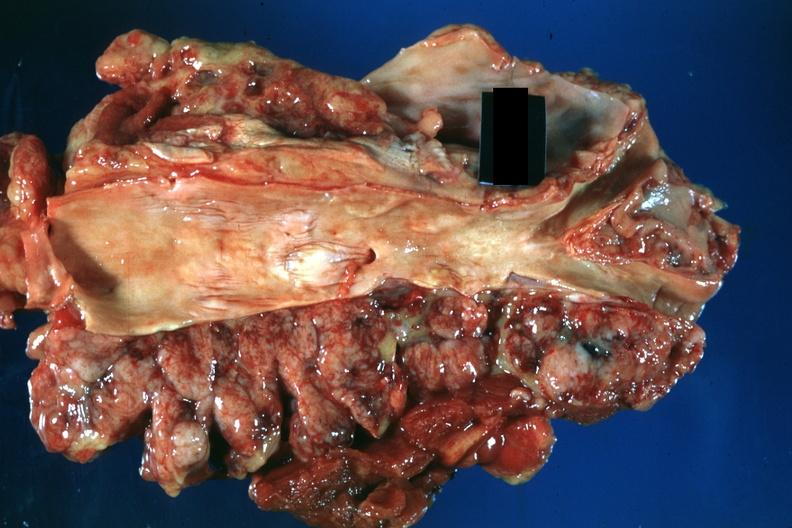what is present?
Answer the question using a single word or phrase. Large cell lymphoma 